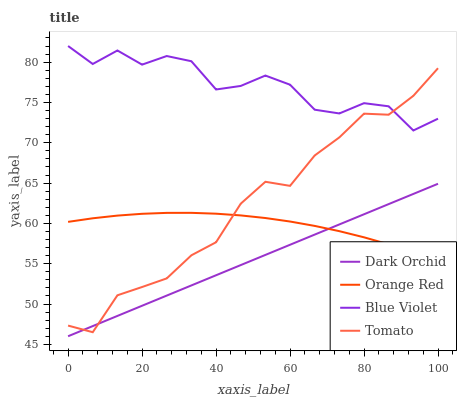Does Dark Orchid have the minimum area under the curve?
Answer yes or no. Yes. Does Blue Violet have the maximum area under the curve?
Answer yes or no. Yes. Does Tomato have the minimum area under the curve?
Answer yes or no. No. Does Tomato have the maximum area under the curve?
Answer yes or no. No. Is Dark Orchid the smoothest?
Answer yes or no. Yes. Is Blue Violet the roughest?
Answer yes or no. Yes. Is Tomato the smoothest?
Answer yes or no. No. Is Tomato the roughest?
Answer yes or no. No. Does Tomato have the lowest value?
Answer yes or no. No. Does Tomato have the highest value?
Answer yes or no. No. Is Dark Orchid less than Blue Violet?
Answer yes or no. Yes. Is Blue Violet greater than Dark Orchid?
Answer yes or no. Yes. Does Dark Orchid intersect Blue Violet?
Answer yes or no. No. 